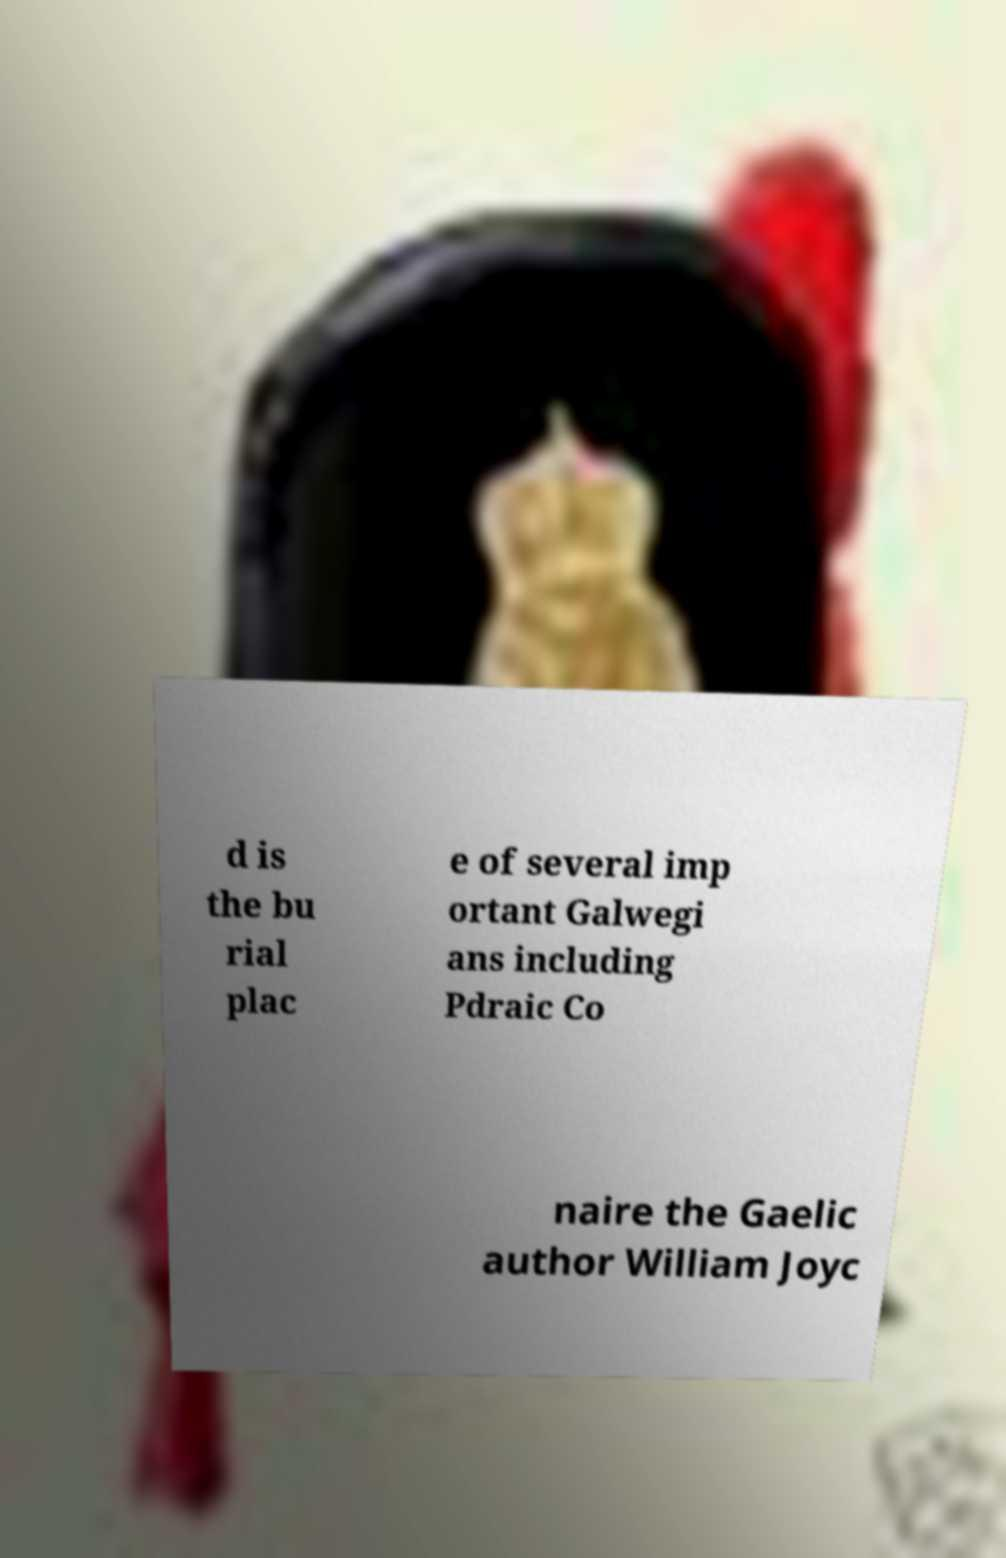Can you accurately transcribe the text from the provided image for me? d is the bu rial plac e of several imp ortant Galwegi ans including Pdraic Co naire the Gaelic author William Joyc 